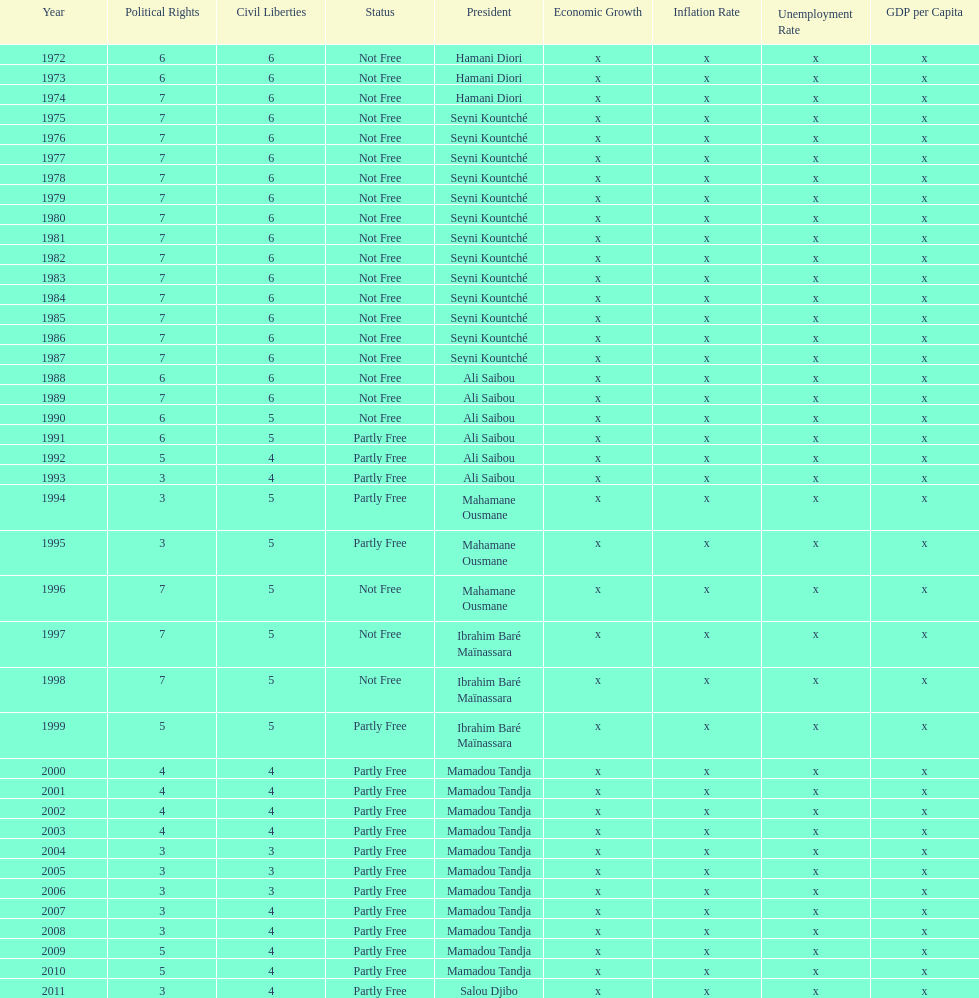Who is the subsequent president mentioned following hamani diori in 1974? Seyni Kountché. 